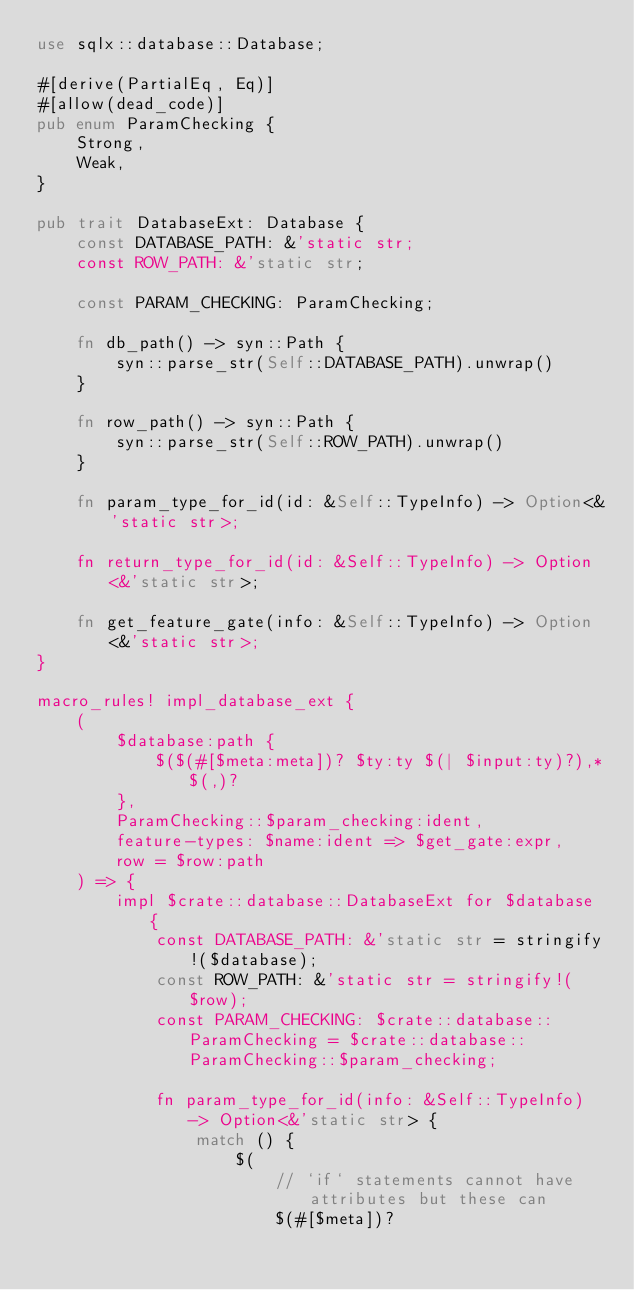Convert code to text. <code><loc_0><loc_0><loc_500><loc_500><_Rust_>use sqlx::database::Database;

#[derive(PartialEq, Eq)]
#[allow(dead_code)]
pub enum ParamChecking {
    Strong,
    Weak,
}

pub trait DatabaseExt: Database {
    const DATABASE_PATH: &'static str;
    const ROW_PATH: &'static str;

    const PARAM_CHECKING: ParamChecking;

    fn db_path() -> syn::Path {
        syn::parse_str(Self::DATABASE_PATH).unwrap()
    }

    fn row_path() -> syn::Path {
        syn::parse_str(Self::ROW_PATH).unwrap()
    }

    fn param_type_for_id(id: &Self::TypeInfo) -> Option<&'static str>;

    fn return_type_for_id(id: &Self::TypeInfo) -> Option<&'static str>;

    fn get_feature_gate(info: &Self::TypeInfo) -> Option<&'static str>;
}

macro_rules! impl_database_ext {
    (
        $database:path {
            $($(#[$meta:meta])? $ty:ty $(| $input:ty)?),*$(,)?
        },
        ParamChecking::$param_checking:ident,
        feature-types: $name:ident => $get_gate:expr,
        row = $row:path
    ) => {
        impl $crate::database::DatabaseExt for $database {
            const DATABASE_PATH: &'static str = stringify!($database);
            const ROW_PATH: &'static str = stringify!($row);
            const PARAM_CHECKING: $crate::database::ParamChecking = $crate::database::ParamChecking::$param_checking;

            fn param_type_for_id(info: &Self::TypeInfo) -> Option<&'static str> {
                match () {
                    $(
                        // `if` statements cannot have attributes but these can
                        $(#[$meta])?</code> 